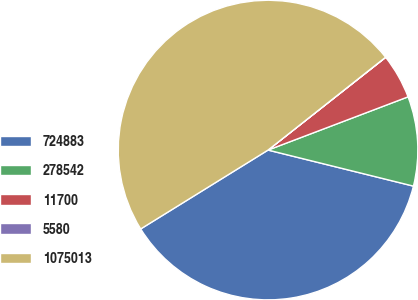<chart> <loc_0><loc_0><loc_500><loc_500><pie_chart><fcel>724883<fcel>278542<fcel>11700<fcel>5580<fcel>1075013<nl><fcel>37.3%<fcel>9.65%<fcel>4.84%<fcel>0.02%<fcel>48.18%<nl></chart> 